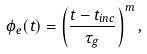<formula> <loc_0><loc_0><loc_500><loc_500>\phi _ { e } ( t ) = \left ( \frac { t - t _ { i n c } } { \tau _ { g } } \right ) ^ { m } ,</formula> 